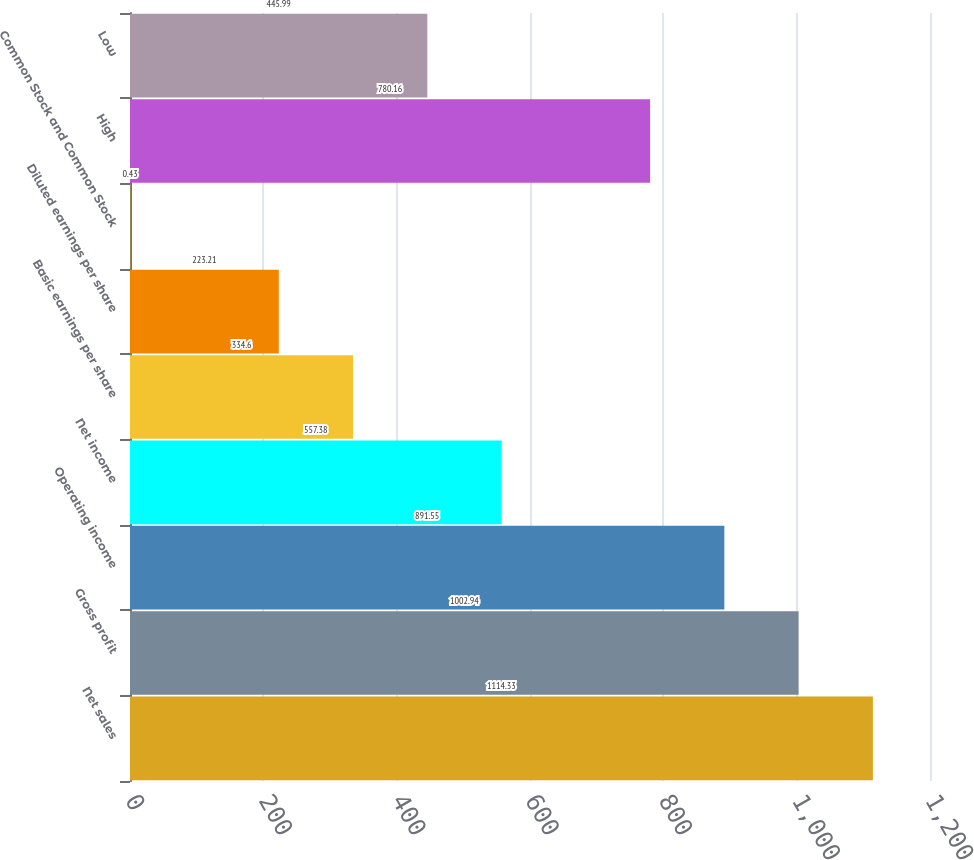Convert chart. <chart><loc_0><loc_0><loc_500><loc_500><bar_chart><fcel>Net sales<fcel>Gross profit<fcel>Operating income<fcel>Net income<fcel>Basic earnings per share<fcel>Diluted earnings per share<fcel>Common Stock and Common Stock<fcel>High<fcel>Low<nl><fcel>1114.33<fcel>1002.94<fcel>891.55<fcel>557.38<fcel>334.6<fcel>223.21<fcel>0.43<fcel>780.16<fcel>445.99<nl></chart> 